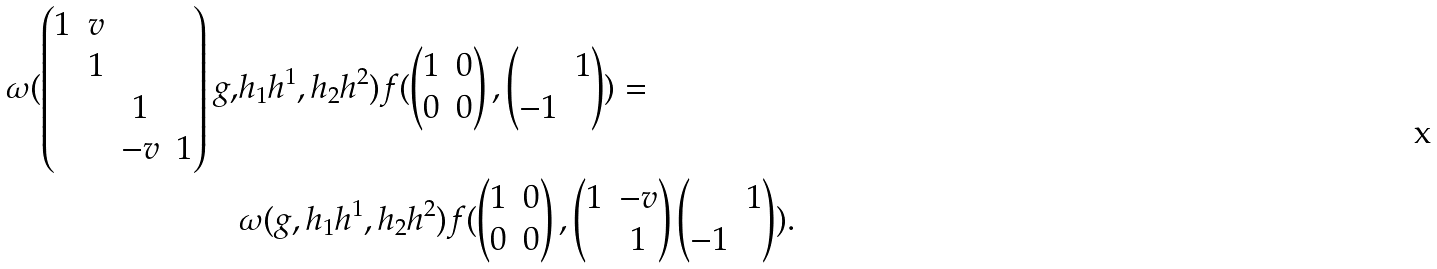Convert formula to latex. <formula><loc_0><loc_0><loc_500><loc_500>\omega ( \begin{pmatrix} 1 & v \\ & 1 \\ & & 1 \\ & & - v & 1 \end{pmatrix} g , & h _ { 1 } h ^ { 1 } , h _ { 2 } h ^ { 2 } ) f ( \begin{pmatrix} 1 & 0 \\ 0 & 0 \end{pmatrix} , \begin{pmatrix} & 1 \\ - 1 \end{pmatrix} ) = \\ & \omega ( g , h _ { 1 } h ^ { 1 } , h _ { 2 } h ^ { 2 } ) f ( \begin{pmatrix} 1 & 0 \\ 0 & 0 \end{pmatrix} , \begin{pmatrix} 1 & - v \\ & 1 \end{pmatrix} \begin{pmatrix} & 1 \\ - 1 \end{pmatrix} ) .</formula> 